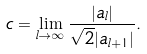Convert formula to latex. <formula><loc_0><loc_0><loc_500><loc_500>c = \lim _ { l \rightarrow \infty } \frac { | a _ { l } | } { \sqrt { 2 } | a _ { l + 1 } | } .</formula> 